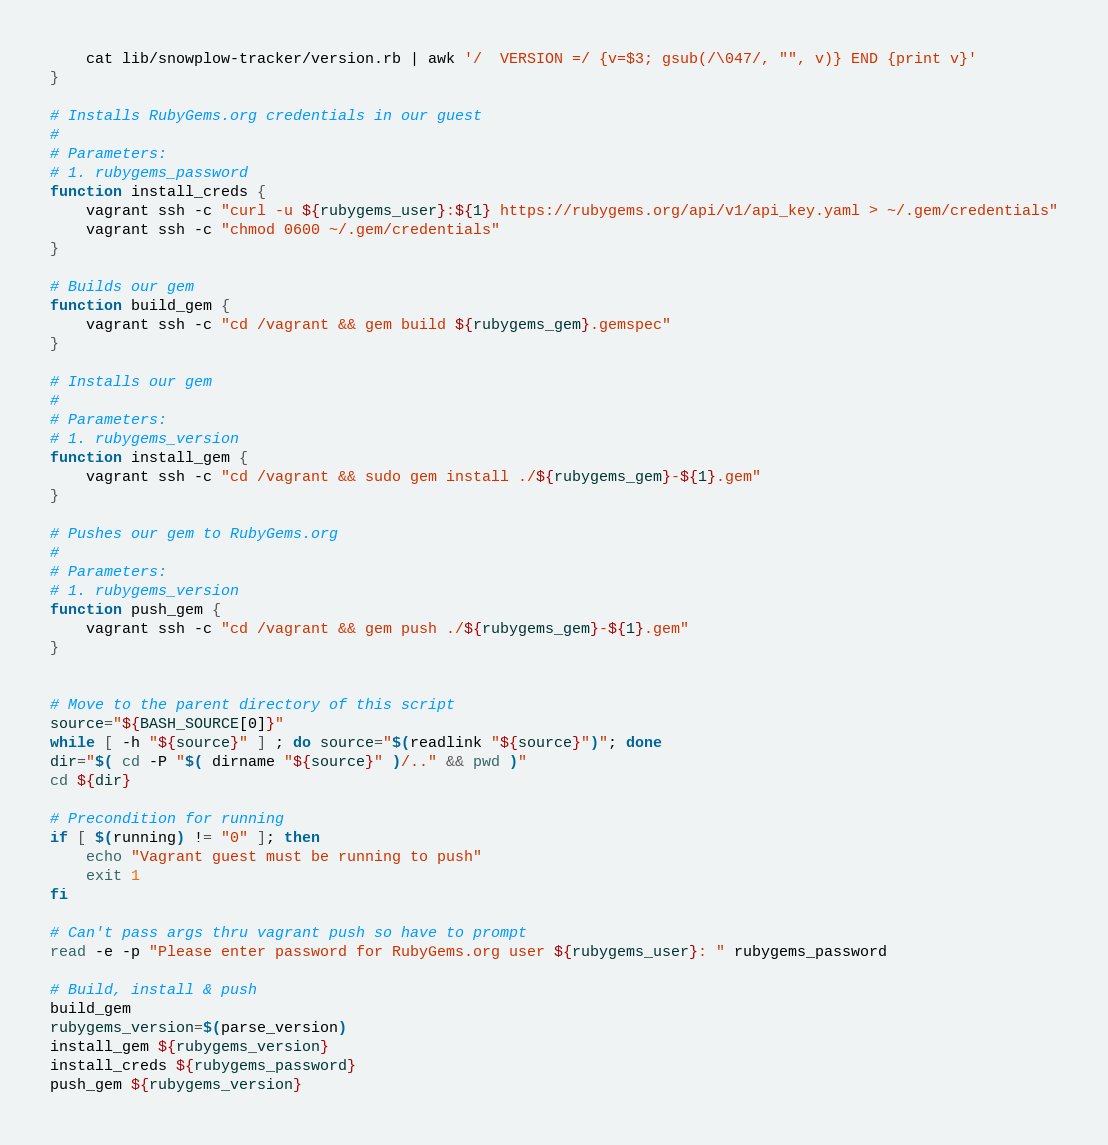<code> <loc_0><loc_0><loc_500><loc_500><_Bash_>    cat lib/snowplow-tracker/version.rb | awk '/  VERSION =/ {v=$3; gsub(/\047/, "", v)} END {print v}'
}

# Installs RubyGems.org credentials in our guest
#
# Parameters:
# 1. rubygems_password
function install_creds {
    vagrant ssh -c "curl -u ${rubygems_user}:${1} https://rubygems.org/api/v1/api_key.yaml > ~/.gem/credentials"
    vagrant ssh -c "chmod 0600 ~/.gem/credentials"
}

# Builds our gem
function build_gem {
    vagrant ssh -c "cd /vagrant && gem build ${rubygems_gem}.gemspec"
}

# Installs our gem
#
# Parameters:
# 1. rubygems_version
function install_gem {
    vagrant ssh -c "cd /vagrant && sudo gem install ./${rubygems_gem}-${1}.gem"
}

# Pushes our gem to RubyGems.org
#
# Parameters:
# 1. rubygems_version
function push_gem {
    vagrant ssh -c "cd /vagrant && gem push ./${rubygems_gem}-${1}.gem"
}


# Move to the parent directory of this script
source="${BASH_SOURCE[0]}"
while [ -h "${source}" ] ; do source="$(readlink "${source}")"; done
dir="$( cd -P "$( dirname "${source}" )/.." && pwd )"
cd ${dir}

# Precondition for running
if [ $(running) != "0" ]; then
    echo "Vagrant guest must be running to push"
    exit 1
fi

# Can't pass args thru vagrant push so have to prompt
read -e -p "Please enter password for RubyGems.org user ${rubygems_user}: " rubygems_password

# Build, install & push
build_gem
rubygems_version=$(parse_version)
install_gem ${rubygems_version}
install_creds ${rubygems_password}
push_gem ${rubygems_version}
</code> 